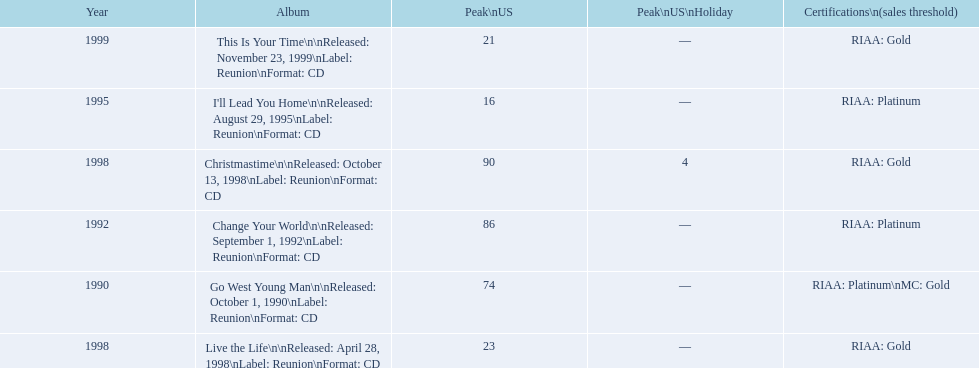How many songs are listed from 1998? 2. 